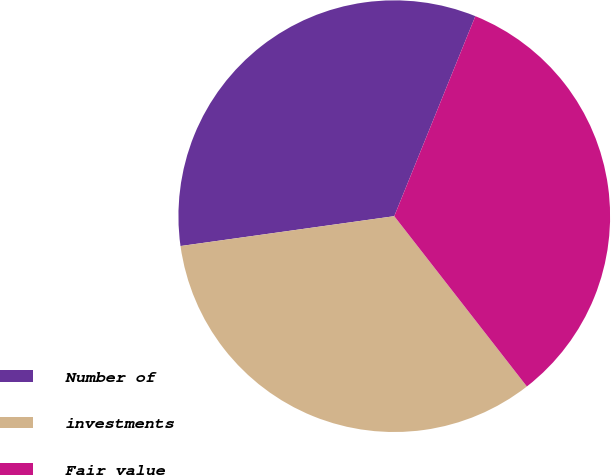<chart> <loc_0><loc_0><loc_500><loc_500><pie_chart><fcel>Number of<fcel>investments<fcel>Fair value<nl><fcel>33.34%<fcel>33.32%<fcel>33.34%<nl></chart> 